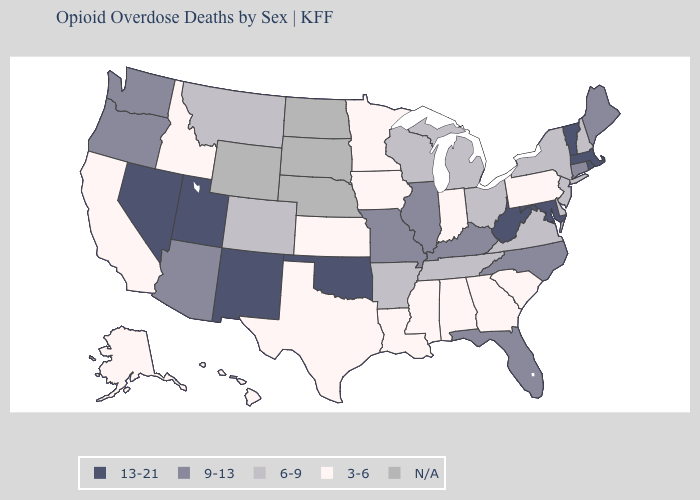What is the highest value in states that border Idaho?
Concise answer only. 13-21. How many symbols are there in the legend?
Give a very brief answer. 5. Name the states that have a value in the range 3-6?
Answer briefly. Alabama, Alaska, California, Georgia, Hawaii, Idaho, Indiana, Iowa, Kansas, Louisiana, Minnesota, Mississippi, Pennsylvania, South Carolina, Texas. What is the lowest value in states that border Georgia?
Short answer required. 3-6. Does Massachusetts have the highest value in the USA?
Quick response, please. Yes. Does Pennsylvania have the highest value in the Northeast?
Quick response, please. No. What is the lowest value in states that border North Dakota?
Give a very brief answer. 3-6. Among the states that border Oregon , does Nevada have the highest value?
Keep it brief. Yes. What is the highest value in the USA?
Concise answer only. 13-21. Name the states that have a value in the range 3-6?
Write a very short answer. Alabama, Alaska, California, Georgia, Hawaii, Idaho, Indiana, Iowa, Kansas, Louisiana, Minnesota, Mississippi, Pennsylvania, South Carolina, Texas. Name the states that have a value in the range 6-9?
Concise answer only. Arkansas, Colorado, Delaware, Michigan, Montana, New Hampshire, New Jersey, New York, Ohio, Tennessee, Virginia, Wisconsin. 